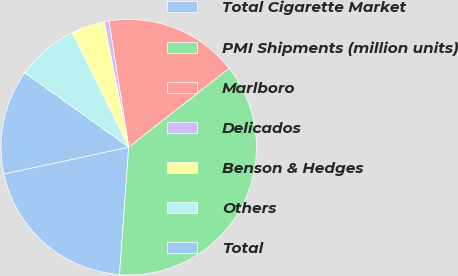<chart> <loc_0><loc_0><loc_500><loc_500><pie_chart><fcel>Total Cigarette Market<fcel>PMI Shipments (million units)<fcel>Marlboro<fcel>Delicados<fcel>Benson & Hedges<fcel>Others<fcel>Total<nl><fcel>20.48%<fcel>36.75%<fcel>16.87%<fcel>0.6%<fcel>4.22%<fcel>7.83%<fcel>13.25%<nl></chart> 